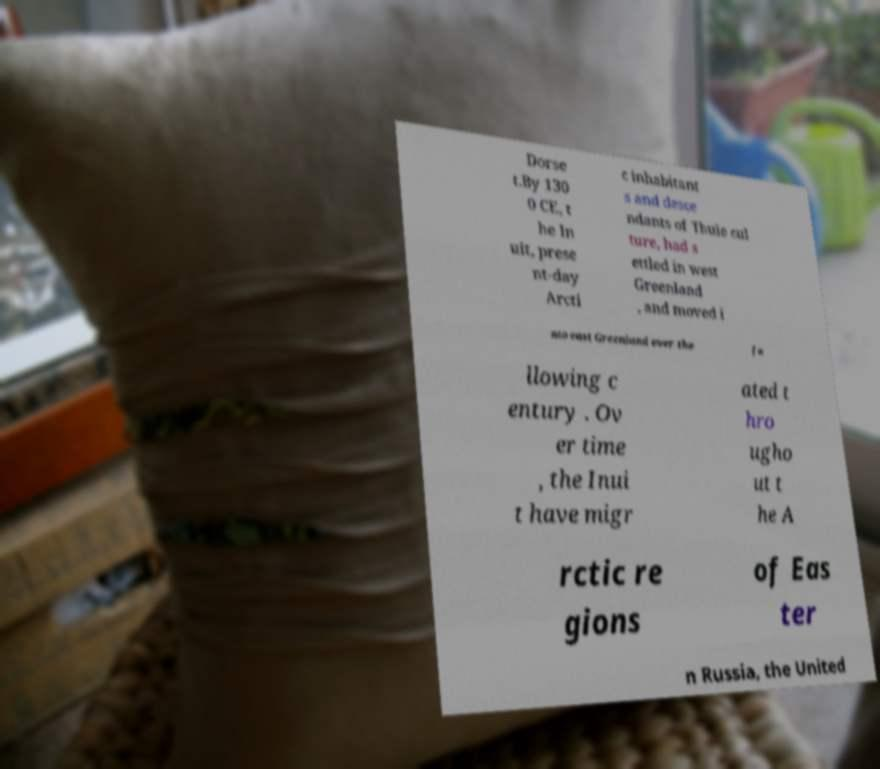Could you assist in decoding the text presented in this image and type it out clearly? Dorse t.By 130 0 CE, t he In uit, prese nt-day Arcti c inhabitant s and desce ndants of Thule cul ture, had s ettled in west Greenland , and moved i nto east Greenland over the fo llowing c entury . Ov er time , the Inui t have migr ated t hro ugho ut t he A rctic re gions of Eas ter n Russia, the United 